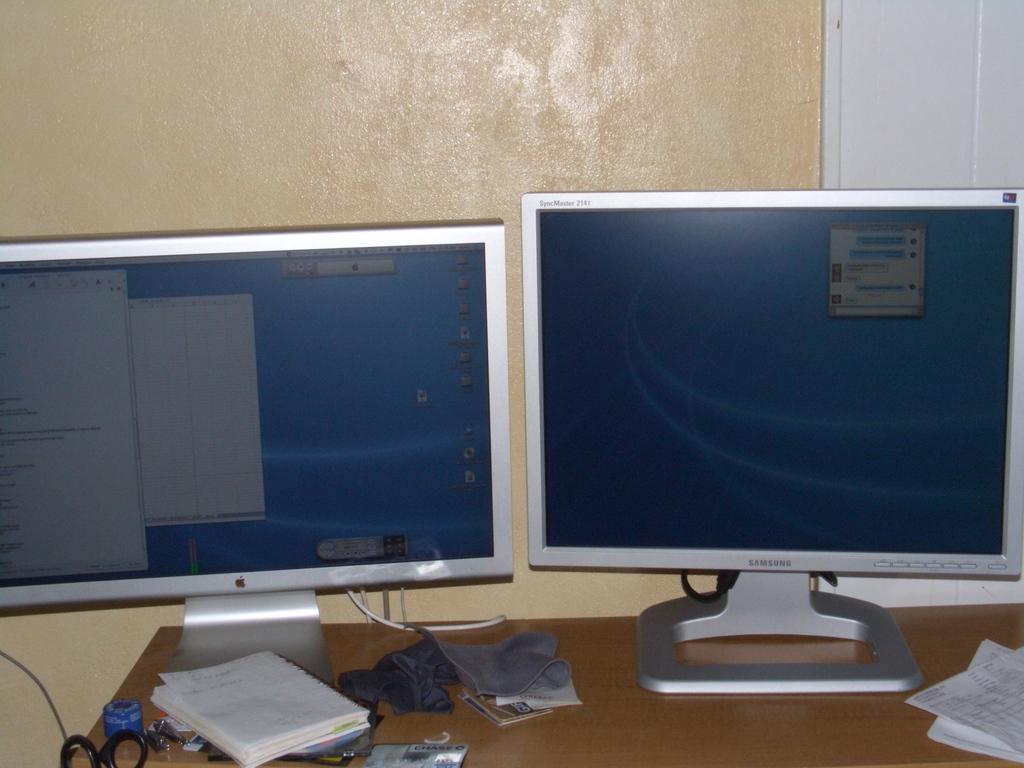What brand is the monitor on the right?
Make the answer very short. Samsung. 